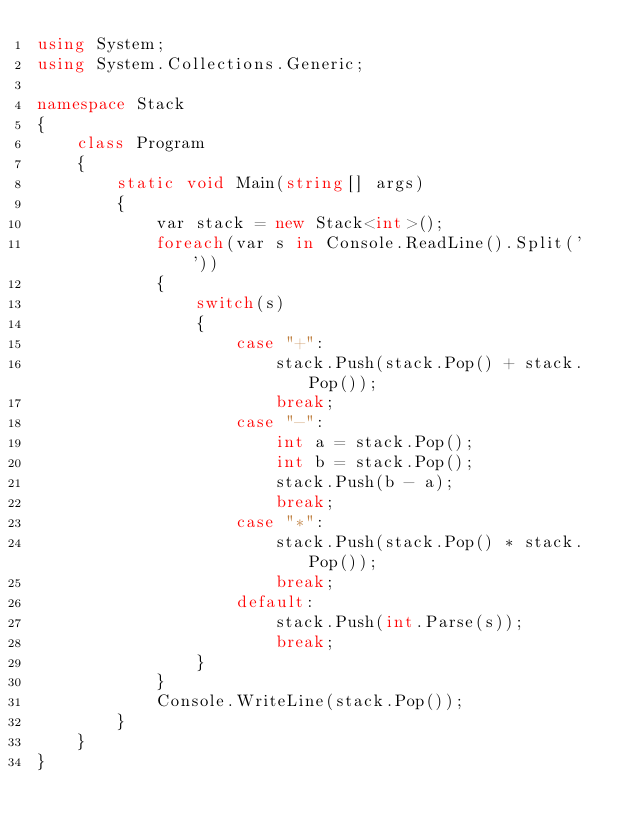Convert code to text. <code><loc_0><loc_0><loc_500><loc_500><_C#_>using System;
using System.Collections.Generic;

namespace Stack
{
    class Program
    {
        static void Main(string[] args)
        {
            var stack = new Stack<int>(); 
            foreach(var s in Console.ReadLine().Split(' '))
            {
                switch(s)
                {
                    case "+":
                        stack.Push(stack.Pop() + stack.Pop());
                        break;
                    case "-":
                        int a = stack.Pop();
                        int b = stack.Pop();
                        stack.Push(b - a);
                        break;
                    case "*":
                        stack.Push(stack.Pop() * stack.Pop());
                        break;
                    default:
                        stack.Push(int.Parse(s));
                        break;
                }
            }
            Console.WriteLine(stack.Pop());
        }
    }
}

</code> 